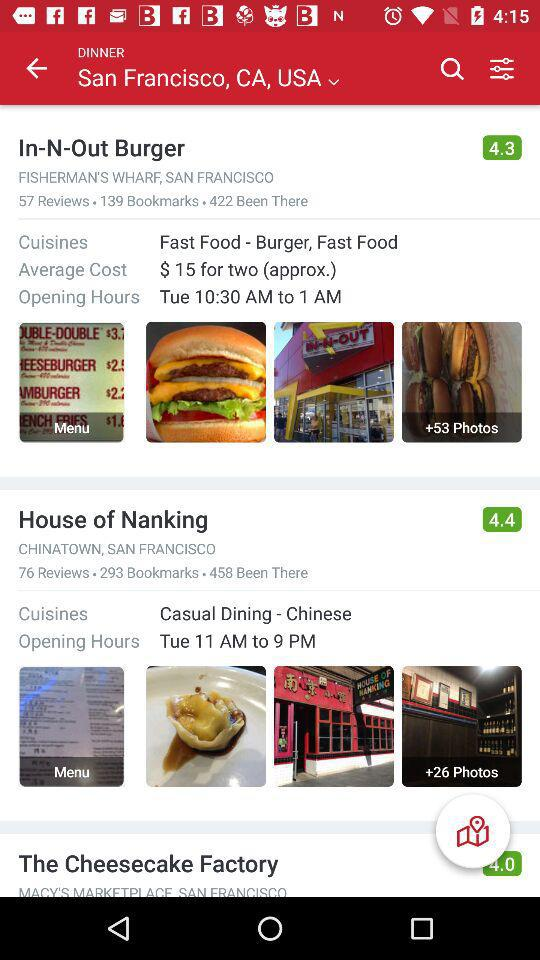What are the opening hours for "In-N-Out Burger"? The opening hours for "In-N-Out Burger" are from 10:30 a.m. to 1 a.m. 